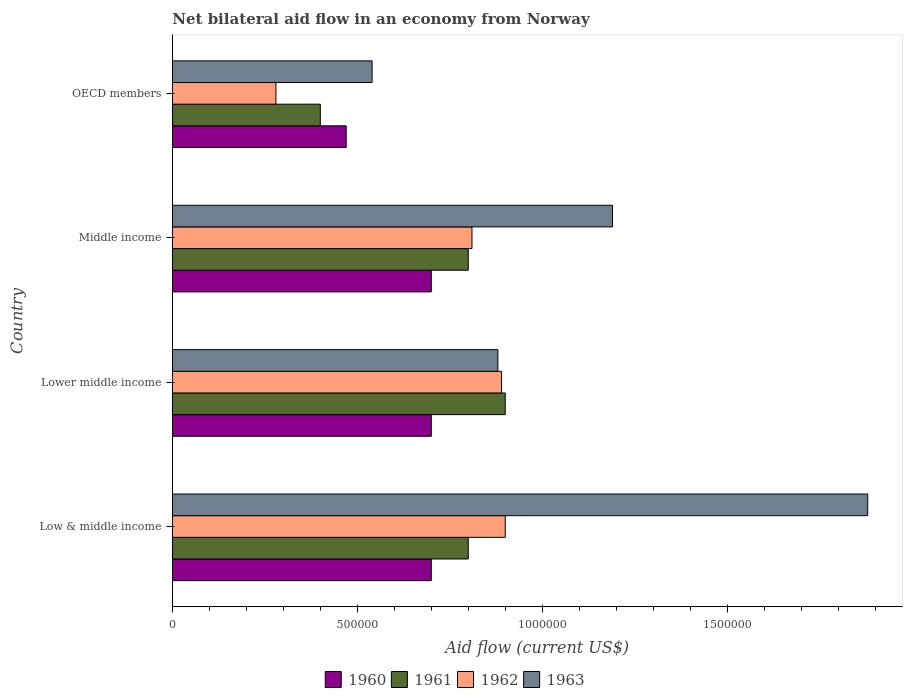How many different coloured bars are there?
Make the answer very short. 4. Are the number of bars on each tick of the Y-axis equal?
Make the answer very short. Yes. What is the label of the 3rd group of bars from the top?
Offer a very short reply. Lower middle income. What is the net bilateral aid flow in 1962 in Lower middle income?
Ensure brevity in your answer.  8.90e+05. Across all countries, what is the minimum net bilateral aid flow in 1960?
Make the answer very short. 4.70e+05. In which country was the net bilateral aid flow in 1963 maximum?
Make the answer very short. Low & middle income. What is the total net bilateral aid flow in 1962 in the graph?
Your answer should be very brief. 2.88e+06. What is the difference between the net bilateral aid flow in 1962 in Middle income and that in OECD members?
Offer a very short reply. 5.30e+05. What is the average net bilateral aid flow in 1961 per country?
Provide a succinct answer. 7.25e+05. In how many countries, is the net bilateral aid flow in 1963 greater than 1600000 US$?
Make the answer very short. 1. What is the ratio of the net bilateral aid flow in 1963 in Low & middle income to that in Middle income?
Your response must be concise. 1.58. What is the difference between the highest and the lowest net bilateral aid flow in 1963?
Your response must be concise. 1.34e+06. Is the sum of the net bilateral aid flow in 1963 in Lower middle income and Middle income greater than the maximum net bilateral aid flow in 1960 across all countries?
Provide a succinct answer. Yes. Is it the case that in every country, the sum of the net bilateral aid flow in 1961 and net bilateral aid flow in 1963 is greater than the sum of net bilateral aid flow in 1960 and net bilateral aid flow in 1962?
Ensure brevity in your answer.  No. What does the 2nd bar from the top in Lower middle income represents?
Offer a terse response. 1962. Is it the case that in every country, the sum of the net bilateral aid flow in 1963 and net bilateral aid flow in 1961 is greater than the net bilateral aid flow in 1962?
Ensure brevity in your answer.  Yes. How many bars are there?
Offer a terse response. 16. Are the values on the major ticks of X-axis written in scientific E-notation?
Your answer should be very brief. No. Does the graph contain any zero values?
Your response must be concise. No. Where does the legend appear in the graph?
Make the answer very short. Bottom center. How are the legend labels stacked?
Give a very brief answer. Horizontal. What is the title of the graph?
Your response must be concise. Net bilateral aid flow in an economy from Norway. Does "1995" appear as one of the legend labels in the graph?
Offer a very short reply. No. What is the label or title of the X-axis?
Your answer should be very brief. Aid flow (current US$). What is the label or title of the Y-axis?
Your response must be concise. Country. What is the Aid flow (current US$) in 1960 in Low & middle income?
Your answer should be compact. 7.00e+05. What is the Aid flow (current US$) in 1963 in Low & middle income?
Your answer should be very brief. 1.88e+06. What is the Aid flow (current US$) in 1962 in Lower middle income?
Make the answer very short. 8.90e+05. What is the Aid flow (current US$) of 1963 in Lower middle income?
Your answer should be compact. 8.80e+05. What is the Aid flow (current US$) in 1961 in Middle income?
Your response must be concise. 8.00e+05. What is the Aid flow (current US$) in 1962 in Middle income?
Provide a short and direct response. 8.10e+05. What is the Aid flow (current US$) of 1963 in Middle income?
Offer a terse response. 1.19e+06. What is the Aid flow (current US$) in 1960 in OECD members?
Give a very brief answer. 4.70e+05. What is the Aid flow (current US$) of 1961 in OECD members?
Give a very brief answer. 4.00e+05. What is the Aid flow (current US$) in 1962 in OECD members?
Offer a terse response. 2.80e+05. What is the Aid flow (current US$) in 1963 in OECD members?
Provide a succinct answer. 5.40e+05. Across all countries, what is the maximum Aid flow (current US$) of 1962?
Ensure brevity in your answer.  9.00e+05. Across all countries, what is the maximum Aid flow (current US$) in 1963?
Ensure brevity in your answer.  1.88e+06. Across all countries, what is the minimum Aid flow (current US$) of 1962?
Give a very brief answer. 2.80e+05. Across all countries, what is the minimum Aid flow (current US$) in 1963?
Your response must be concise. 5.40e+05. What is the total Aid flow (current US$) of 1960 in the graph?
Provide a short and direct response. 2.57e+06. What is the total Aid flow (current US$) of 1961 in the graph?
Your response must be concise. 2.90e+06. What is the total Aid flow (current US$) of 1962 in the graph?
Give a very brief answer. 2.88e+06. What is the total Aid flow (current US$) in 1963 in the graph?
Offer a very short reply. 4.49e+06. What is the difference between the Aid flow (current US$) of 1960 in Low & middle income and that in Lower middle income?
Provide a short and direct response. 0. What is the difference between the Aid flow (current US$) in 1962 in Low & middle income and that in Lower middle income?
Your response must be concise. 10000. What is the difference between the Aid flow (current US$) of 1960 in Low & middle income and that in Middle income?
Your answer should be very brief. 0. What is the difference between the Aid flow (current US$) in 1962 in Low & middle income and that in Middle income?
Your answer should be very brief. 9.00e+04. What is the difference between the Aid flow (current US$) of 1963 in Low & middle income and that in Middle income?
Your response must be concise. 6.90e+05. What is the difference between the Aid flow (current US$) in 1960 in Low & middle income and that in OECD members?
Offer a terse response. 2.30e+05. What is the difference between the Aid flow (current US$) in 1962 in Low & middle income and that in OECD members?
Ensure brevity in your answer.  6.20e+05. What is the difference between the Aid flow (current US$) of 1963 in Low & middle income and that in OECD members?
Ensure brevity in your answer.  1.34e+06. What is the difference between the Aid flow (current US$) of 1960 in Lower middle income and that in Middle income?
Offer a very short reply. 0. What is the difference between the Aid flow (current US$) in 1963 in Lower middle income and that in Middle income?
Keep it short and to the point. -3.10e+05. What is the difference between the Aid flow (current US$) in 1960 in Lower middle income and that in OECD members?
Give a very brief answer. 2.30e+05. What is the difference between the Aid flow (current US$) of 1961 in Lower middle income and that in OECD members?
Keep it short and to the point. 5.00e+05. What is the difference between the Aid flow (current US$) in 1963 in Lower middle income and that in OECD members?
Ensure brevity in your answer.  3.40e+05. What is the difference between the Aid flow (current US$) of 1960 in Middle income and that in OECD members?
Provide a succinct answer. 2.30e+05. What is the difference between the Aid flow (current US$) in 1961 in Middle income and that in OECD members?
Provide a succinct answer. 4.00e+05. What is the difference between the Aid flow (current US$) of 1962 in Middle income and that in OECD members?
Provide a short and direct response. 5.30e+05. What is the difference between the Aid flow (current US$) in 1963 in Middle income and that in OECD members?
Your answer should be compact. 6.50e+05. What is the difference between the Aid flow (current US$) of 1960 in Low & middle income and the Aid flow (current US$) of 1961 in Lower middle income?
Provide a succinct answer. -2.00e+05. What is the difference between the Aid flow (current US$) of 1961 in Low & middle income and the Aid flow (current US$) of 1963 in Lower middle income?
Provide a short and direct response. -8.00e+04. What is the difference between the Aid flow (current US$) in 1960 in Low & middle income and the Aid flow (current US$) in 1961 in Middle income?
Offer a terse response. -1.00e+05. What is the difference between the Aid flow (current US$) of 1960 in Low & middle income and the Aid flow (current US$) of 1962 in Middle income?
Your response must be concise. -1.10e+05. What is the difference between the Aid flow (current US$) of 1960 in Low & middle income and the Aid flow (current US$) of 1963 in Middle income?
Give a very brief answer. -4.90e+05. What is the difference between the Aid flow (current US$) in 1961 in Low & middle income and the Aid flow (current US$) in 1962 in Middle income?
Keep it short and to the point. -10000. What is the difference between the Aid flow (current US$) in 1961 in Low & middle income and the Aid flow (current US$) in 1963 in Middle income?
Ensure brevity in your answer.  -3.90e+05. What is the difference between the Aid flow (current US$) in 1960 in Low & middle income and the Aid flow (current US$) in 1962 in OECD members?
Give a very brief answer. 4.20e+05. What is the difference between the Aid flow (current US$) in 1961 in Low & middle income and the Aid flow (current US$) in 1962 in OECD members?
Your answer should be very brief. 5.20e+05. What is the difference between the Aid flow (current US$) in 1961 in Low & middle income and the Aid flow (current US$) in 1963 in OECD members?
Your answer should be very brief. 2.60e+05. What is the difference between the Aid flow (current US$) in 1960 in Lower middle income and the Aid flow (current US$) in 1961 in Middle income?
Your response must be concise. -1.00e+05. What is the difference between the Aid flow (current US$) of 1960 in Lower middle income and the Aid flow (current US$) of 1962 in Middle income?
Ensure brevity in your answer.  -1.10e+05. What is the difference between the Aid flow (current US$) in 1960 in Lower middle income and the Aid flow (current US$) in 1963 in Middle income?
Make the answer very short. -4.90e+05. What is the difference between the Aid flow (current US$) of 1961 in Lower middle income and the Aid flow (current US$) of 1962 in Middle income?
Your answer should be compact. 9.00e+04. What is the difference between the Aid flow (current US$) in 1962 in Lower middle income and the Aid flow (current US$) in 1963 in Middle income?
Your answer should be very brief. -3.00e+05. What is the difference between the Aid flow (current US$) of 1960 in Lower middle income and the Aid flow (current US$) of 1962 in OECD members?
Keep it short and to the point. 4.20e+05. What is the difference between the Aid flow (current US$) in 1960 in Lower middle income and the Aid flow (current US$) in 1963 in OECD members?
Keep it short and to the point. 1.60e+05. What is the difference between the Aid flow (current US$) in 1961 in Lower middle income and the Aid flow (current US$) in 1962 in OECD members?
Make the answer very short. 6.20e+05. What is the difference between the Aid flow (current US$) of 1961 in Lower middle income and the Aid flow (current US$) of 1963 in OECD members?
Your answer should be very brief. 3.60e+05. What is the difference between the Aid flow (current US$) in 1960 in Middle income and the Aid flow (current US$) in 1961 in OECD members?
Make the answer very short. 3.00e+05. What is the difference between the Aid flow (current US$) of 1960 in Middle income and the Aid flow (current US$) of 1962 in OECD members?
Your answer should be very brief. 4.20e+05. What is the difference between the Aid flow (current US$) of 1961 in Middle income and the Aid flow (current US$) of 1962 in OECD members?
Offer a very short reply. 5.20e+05. What is the difference between the Aid flow (current US$) in 1961 in Middle income and the Aid flow (current US$) in 1963 in OECD members?
Keep it short and to the point. 2.60e+05. What is the difference between the Aid flow (current US$) in 1962 in Middle income and the Aid flow (current US$) in 1963 in OECD members?
Ensure brevity in your answer.  2.70e+05. What is the average Aid flow (current US$) of 1960 per country?
Give a very brief answer. 6.42e+05. What is the average Aid flow (current US$) in 1961 per country?
Provide a short and direct response. 7.25e+05. What is the average Aid flow (current US$) of 1962 per country?
Your answer should be very brief. 7.20e+05. What is the average Aid flow (current US$) in 1963 per country?
Ensure brevity in your answer.  1.12e+06. What is the difference between the Aid flow (current US$) in 1960 and Aid flow (current US$) in 1962 in Low & middle income?
Provide a short and direct response. -2.00e+05. What is the difference between the Aid flow (current US$) in 1960 and Aid flow (current US$) in 1963 in Low & middle income?
Keep it short and to the point. -1.18e+06. What is the difference between the Aid flow (current US$) in 1961 and Aid flow (current US$) in 1963 in Low & middle income?
Provide a short and direct response. -1.08e+06. What is the difference between the Aid flow (current US$) of 1962 and Aid flow (current US$) of 1963 in Low & middle income?
Provide a short and direct response. -9.80e+05. What is the difference between the Aid flow (current US$) in 1961 and Aid flow (current US$) in 1963 in Lower middle income?
Offer a terse response. 2.00e+04. What is the difference between the Aid flow (current US$) in 1962 and Aid flow (current US$) in 1963 in Lower middle income?
Give a very brief answer. 10000. What is the difference between the Aid flow (current US$) of 1960 and Aid flow (current US$) of 1963 in Middle income?
Provide a short and direct response. -4.90e+05. What is the difference between the Aid flow (current US$) in 1961 and Aid flow (current US$) in 1962 in Middle income?
Give a very brief answer. -10000. What is the difference between the Aid flow (current US$) of 1961 and Aid flow (current US$) of 1963 in Middle income?
Your response must be concise. -3.90e+05. What is the difference between the Aid flow (current US$) of 1962 and Aid flow (current US$) of 1963 in Middle income?
Ensure brevity in your answer.  -3.80e+05. What is the difference between the Aid flow (current US$) in 1960 and Aid flow (current US$) in 1962 in OECD members?
Your response must be concise. 1.90e+05. What is the difference between the Aid flow (current US$) in 1961 and Aid flow (current US$) in 1962 in OECD members?
Provide a short and direct response. 1.20e+05. What is the ratio of the Aid flow (current US$) of 1962 in Low & middle income to that in Lower middle income?
Offer a terse response. 1.01. What is the ratio of the Aid flow (current US$) in 1963 in Low & middle income to that in Lower middle income?
Your response must be concise. 2.14. What is the ratio of the Aid flow (current US$) in 1960 in Low & middle income to that in Middle income?
Make the answer very short. 1. What is the ratio of the Aid flow (current US$) in 1962 in Low & middle income to that in Middle income?
Your answer should be very brief. 1.11. What is the ratio of the Aid flow (current US$) of 1963 in Low & middle income to that in Middle income?
Provide a succinct answer. 1.58. What is the ratio of the Aid flow (current US$) of 1960 in Low & middle income to that in OECD members?
Your answer should be compact. 1.49. What is the ratio of the Aid flow (current US$) in 1961 in Low & middle income to that in OECD members?
Keep it short and to the point. 2. What is the ratio of the Aid flow (current US$) in 1962 in Low & middle income to that in OECD members?
Your response must be concise. 3.21. What is the ratio of the Aid flow (current US$) in 1963 in Low & middle income to that in OECD members?
Ensure brevity in your answer.  3.48. What is the ratio of the Aid flow (current US$) of 1961 in Lower middle income to that in Middle income?
Offer a very short reply. 1.12. What is the ratio of the Aid flow (current US$) in 1962 in Lower middle income to that in Middle income?
Make the answer very short. 1.1. What is the ratio of the Aid flow (current US$) in 1963 in Lower middle income to that in Middle income?
Offer a terse response. 0.74. What is the ratio of the Aid flow (current US$) in 1960 in Lower middle income to that in OECD members?
Your answer should be compact. 1.49. What is the ratio of the Aid flow (current US$) of 1961 in Lower middle income to that in OECD members?
Keep it short and to the point. 2.25. What is the ratio of the Aid flow (current US$) of 1962 in Lower middle income to that in OECD members?
Your response must be concise. 3.18. What is the ratio of the Aid flow (current US$) in 1963 in Lower middle income to that in OECD members?
Offer a very short reply. 1.63. What is the ratio of the Aid flow (current US$) in 1960 in Middle income to that in OECD members?
Provide a succinct answer. 1.49. What is the ratio of the Aid flow (current US$) in 1961 in Middle income to that in OECD members?
Keep it short and to the point. 2. What is the ratio of the Aid flow (current US$) in 1962 in Middle income to that in OECD members?
Your answer should be very brief. 2.89. What is the ratio of the Aid flow (current US$) of 1963 in Middle income to that in OECD members?
Your response must be concise. 2.2. What is the difference between the highest and the second highest Aid flow (current US$) in 1963?
Offer a terse response. 6.90e+05. What is the difference between the highest and the lowest Aid flow (current US$) of 1960?
Ensure brevity in your answer.  2.30e+05. What is the difference between the highest and the lowest Aid flow (current US$) in 1962?
Offer a terse response. 6.20e+05. What is the difference between the highest and the lowest Aid flow (current US$) in 1963?
Offer a terse response. 1.34e+06. 